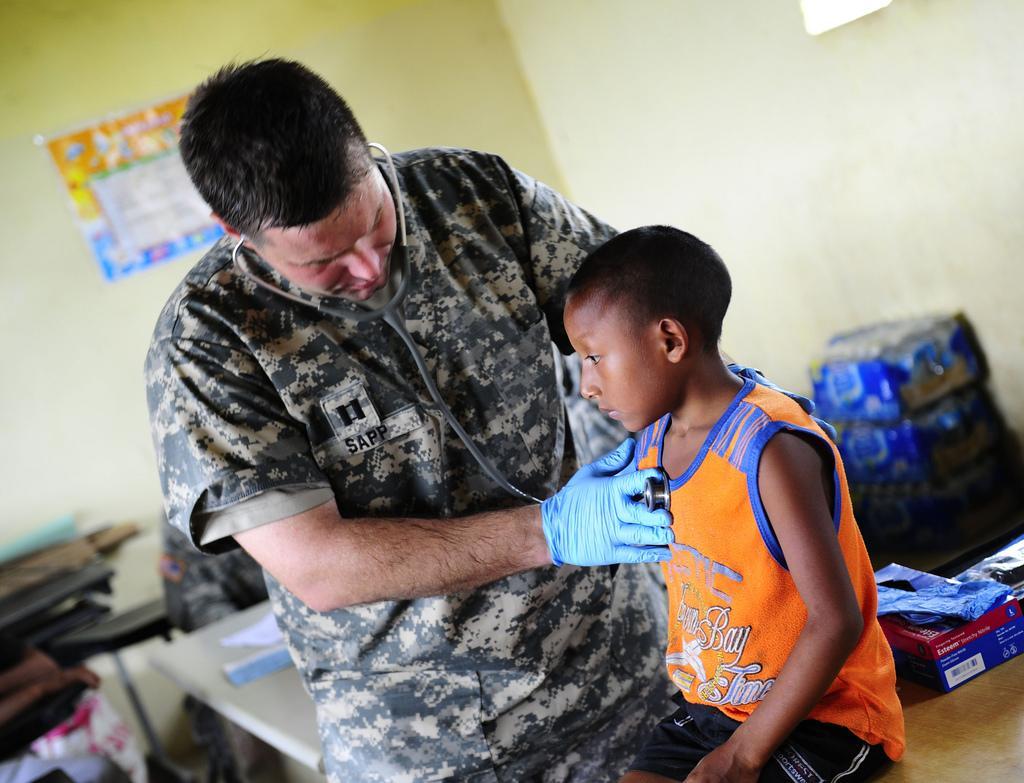Could you give a brief overview of what you see in this image? In this picture we can see two people, stethoscope, tables, box, packets, some objects and in the background we can see a poster on the wall. 